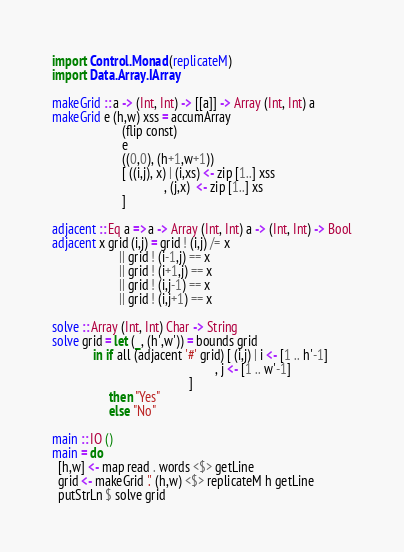Convert code to text. <code><loc_0><loc_0><loc_500><loc_500><_Haskell_>import Control.Monad (replicateM)
import Data.Array.IArray

makeGrid :: a -> (Int, Int) -> [[a]] -> Array (Int, Int) a
makeGrid e (h,w) xss = accumArray
                      (flip const)
                      e
                      ((0,0), (h+1,w+1))
                      [ ((i,j), x) | (i,xs) <- zip [1..] xss
                                   , (j,x)  <- zip [1..] xs
                      ]

adjacent :: Eq a => a -> Array (Int, Int) a -> (Int, Int) -> Bool
adjacent x grid (i,j) = grid ! (i,j) /= x
                     || grid ! (i-1,j) == x
                     || grid ! (i+1,j) == x
                     || grid ! (i,j-1) == x
                     || grid ! (i,j+1) == x

solve :: Array (Int, Int) Char -> String
solve grid = let (_, (h',w')) = bounds grid
             in if all (adjacent '#' grid) [ (i,j) | i <- [1 .. h'-1]
                                                   , j <- [1 .. w'-1]
                                           ]
                  then "Yes"
                  else "No"

main :: IO ()
main = do
  [h,w] <- map read . words <$> getLine
  grid <- makeGrid '.' (h,w) <$> replicateM h getLine
  putStrLn $ solve grid
</code> 